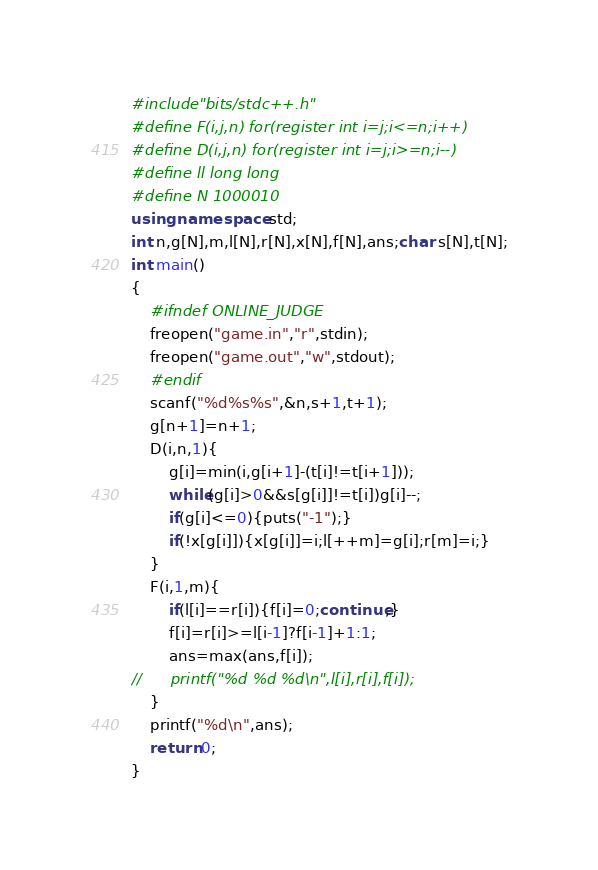<code> <loc_0><loc_0><loc_500><loc_500><_C++_>#include"bits/stdc++.h"
#define F(i,j,n) for(register int i=j;i<=n;i++)
#define D(i,j,n) for(register int i=j;i>=n;i--)
#define ll long long
#define N 1000010
using namespace std;
int n,g[N],m,l[N],r[N],x[N],f[N],ans;char s[N],t[N];
int main()
{
	#ifndef ONLINE_JUDGE
	freopen("game.in","r",stdin);
	freopen("game.out","w",stdout);
	#endif
	scanf("%d%s%s",&n,s+1,t+1);
	g[n+1]=n+1;
	D(i,n,1){
		g[i]=min(i,g[i+1]-(t[i]!=t[i+1]));
		while(g[i]>0&&s[g[i]]!=t[i])g[i]--;
		if(g[i]<=0){puts("-1");}
		if(!x[g[i]]){x[g[i]]=i;l[++m]=g[i];r[m]=i;}
	}
	F(i,1,m){
		if(l[i]==r[i]){f[i]=0;continue;}
		f[i]=r[i]>=l[i-1]?f[i-1]+1:1;
		ans=max(ans,f[i]);
//		printf("%d %d %d\n",l[i],r[i],f[i]);
	}
	printf("%d\n",ans);
	return 0;
}
</code> 